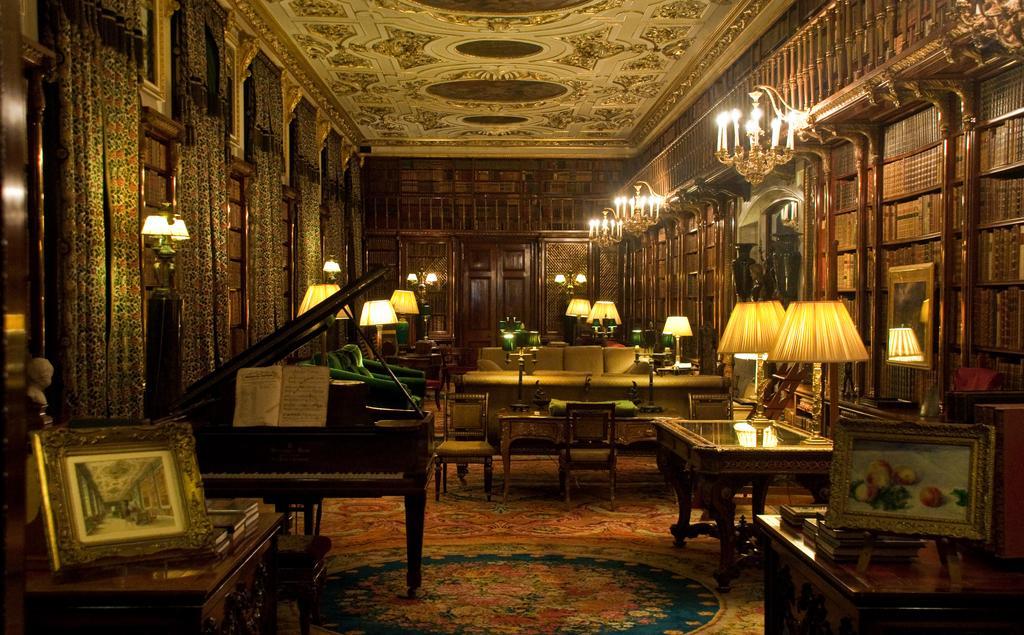How would you summarize this image in a sentence or two? In this image I can see few lamps, few frames, a book, a piano, few curtains, few sofas, candles and number of books. 